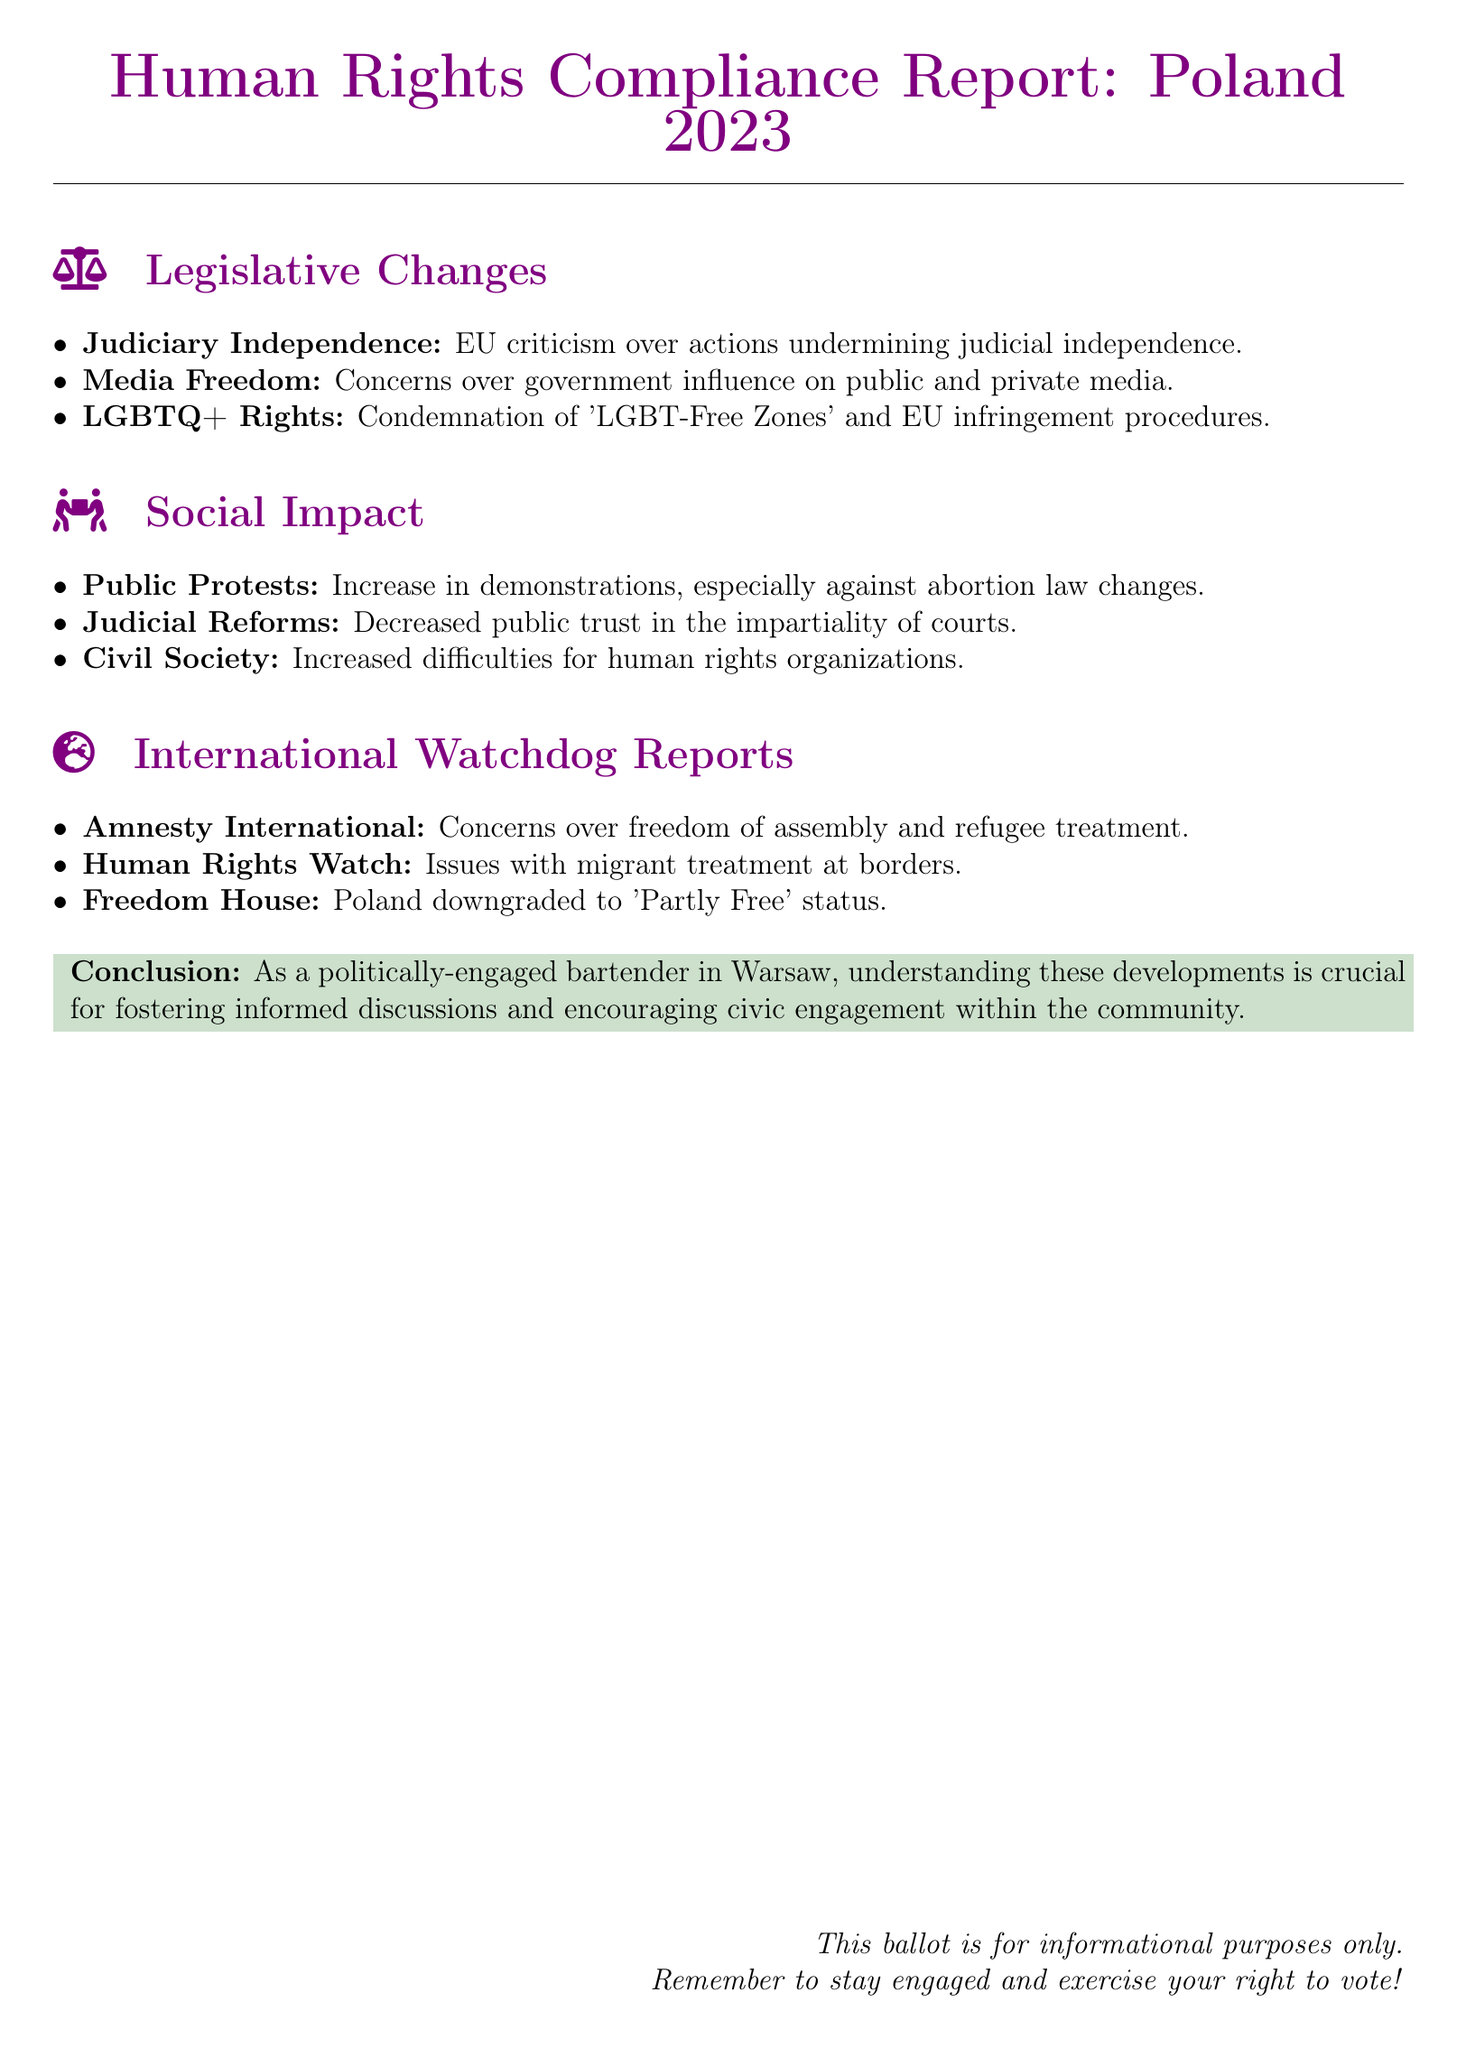What is the title of the report? The title of the report is at the top of the document, indicating the subject of the assessment.
Answer: Human Rights Compliance Report: Poland 2023 Which organization reported concerns over freedom of assembly? The organization that reported concerns is mentioned in the section discussing international watchdog reports.
Answer: Amnesty International What phrase describes areas in Poland affected by government influence on media? This phrase is found under the legislative changes section discussing media.
Answer: Media Freedom What recent social issue saw an increase in demonstrations? The specific social issue is cited in the social impact section of the document.
Answer: Abortion law changes What status was Poland downgraded to by Freedom House? The changed status is mentioned in the international watchdog reports part.
Answer: Partly Free What aspect of the judiciary has faced EU criticism? The aspect facing criticism is highlighted in the legislative changes section.
Answer: Judiciary Independence Which rights group identified issues with migrant treatment? This organization is highlighted in the report discussing international watchdog concerns.
Answer: Human Rights Watch What impact did judicial reforms have on public perception? The impact on public perception is noted in the social impact section.
Answer: Decreased public trust What is the conclusion's main purpose in this report? The conclusion summarizes the significance of the developments discussed in the report.
Answer: Encourage civic engagement 